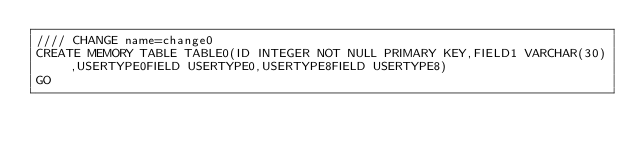Convert code to text. <code><loc_0><loc_0><loc_500><loc_500><_SQL_>//// CHANGE name=change0
CREATE MEMORY TABLE TABLE0(ID INTEGER NOT NULL PRIMARY KEY,FIELD1 VARCHAR(30),USERTYPE0FIELD USERTYPE0,USERTYPE8FIELD USERTYPE8)
GO
</code> 